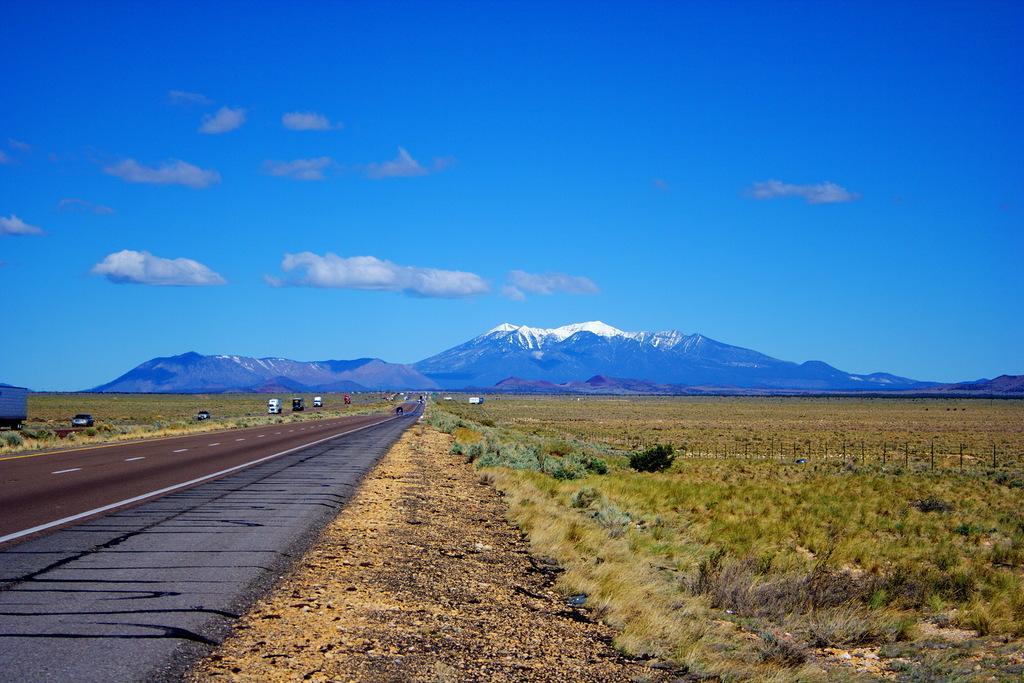Could you give a brief overview of what you see in this image? In this picture we can see the road, vehicles, grass, fence, plants, mountains and in the background we can see the sky with clouds. 